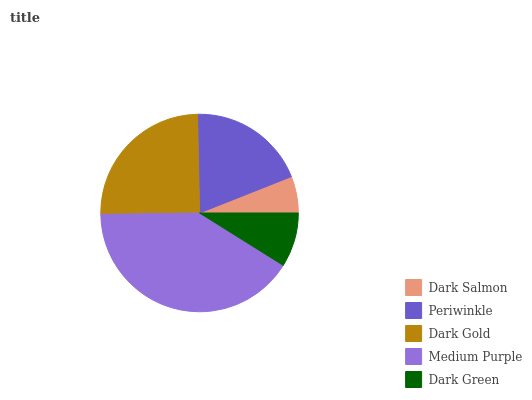Is Dark Salmon the minimum?
Answer yes or no. Yes. Is Medium Purple the maximum?
Answer yes or no. Yes. Is Periwinkle the minimum?
Answer yes or no. No. Is Periwinkle the maximum?
Answer yes or no. No. Is Periwinkle greater than Dark Salmon?
Answer yes or no. Yes. Is Dark Salmon less than Periwinkle?
Answer yes or no. Yes. Is Dark Salmon greater than Periwinkle?
Answer yes or no. No. Is Periwinkle less than Dark Salmon?
Answer yes or no. No. Is Periwinkle the high median?
Answer yes or no. Yes. Is Periwinkle the low median?
Answer yes or no. Yes. Is Medium Purple the high median?
Answer yes or no. No. Is Medium Purple the low median?
Answer yes or no. No. 